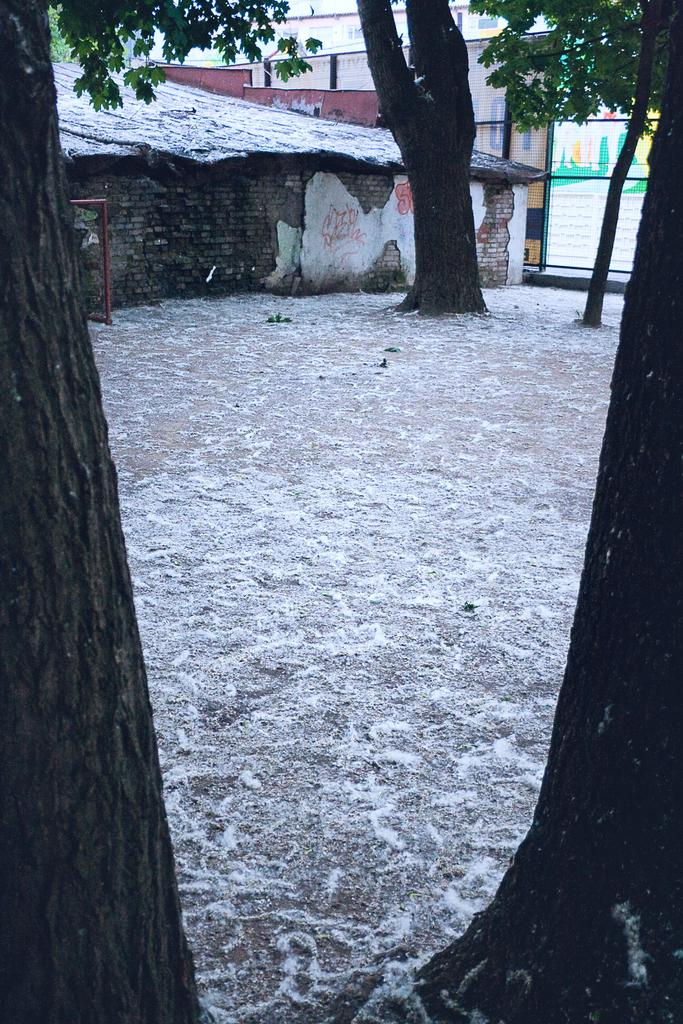What type of natural elements can be seen in the image? There are tree trunks and trees in the image. What type of man-made structures are visible in the image? There are houses and buildings in the image. Can you describe the time of day when the image might have been taken? The image might have been taken during the day, as there is no indication of darkness or artificial lighting. What is the tendency of the branch to grow in the image? There is no branch present in the image, so it is not possible to determine its tendency to grow. 